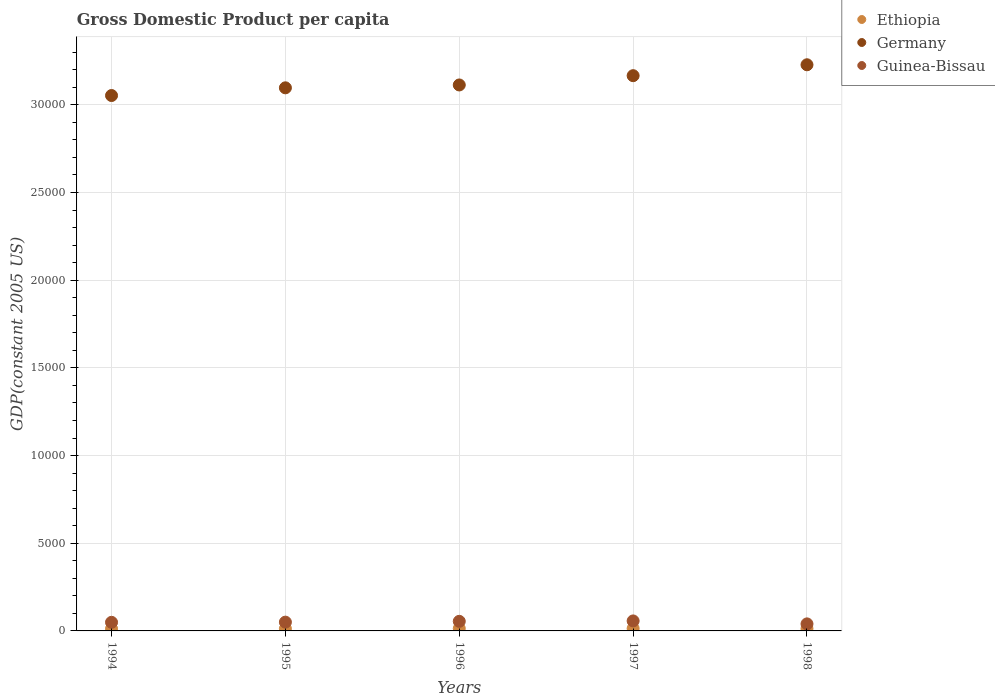What is the GDP per capita in Ethiopia in 1994?
Make the answer very short. 123.73. Across all years, what is the maximum GDP per capita in Guinea-Bissau?
Ensure brevity in your answer.  569.76. Across all years, what is the minimum GDP per capita in Ethiopia?
Offer a terse response. 123.73. In which year was the GDP per capita in Guinea-Bissau maximum?
Make the answer very short. 1997. In which year was the GDP per capita in Ethiopia minimum?
Provide a short and direct response. 1994. What is the total GDP per capita in Guinea-Bissau in the graph?
Ensure brevity in your answer.  2508.49. What is the difference between the GDP per capita in Ethiopia in 1994 and that in 1998?
Give a very brief answer. -6.05. What is the difference between the GDP per capita in Guinea-Bissau in 1998 and the GDP per capita in Ethiopia in 1997?
Your answer should be compact. 262.47. What is the average GDP per capita in Ethiopia per year?
Provide a succinct answer. 131.47. In the year 1994, what is the difference between the GDP per capita in Guinea-Bissau and GDP per capita in Germany?
Make the answer very short. -3.00e+04. What is the ratio of the GDP per capita in Guinea-Bissau in 1997 to that in 1998?
Make the answer very short. 1.42. Is the difference between the GDP per capita in Guinea-Bissau in 1996 and 1997 greater than the difference between the GDP per capita in Germany in 1996 and 1997?
Offer a very short reply. Yes. What is the difference between the highest and the second highest GDP per capita in Guinea-Bissau?
Keep it short and to the point. 23.02. What is the difference between the highest and the lowest GDP per capita in Guinea-Bissau?
Give a very brief answer. 168.85. In how many years, is the GDP per capita in Germany greater than the average GDP per capita in Germany taken over all years?
Your response must be concise. 2. Is the sum of the GDP per capita in Germany in 1994 and 1996 greater than the maximum GDP per capita in Ethiopia across all years?
Your response must be concise. Yes. Is it the case that in every year, the sum of the GDP per capita in Ethiopia and GDP per capita in Guinea-Bissau  is greater than the GDP per capita in Germany?
Your answer should be very brief. No. How many dotlines are there?
Your answer should be very brief. 3. Does the graph contain grids?
Ensure brevity in your answer.  Yes. How many legend labels are there?
Your answer should be compact. 3. How are the legend labels stacked?
Provide a short and direct response. Vertical. What is the title of the graph?
Ensure brevity in your answer.  Gross Domestic Product per capita. Does "Indonesia" appear as one of the legend labels in the graph?
Give a very brief answer. No. What is the label or title of the Y-axis?
Provide a short and direct response. GDP(constant 2005 US). What is the GDP(constant 2005 US) in Ethiopia in 1994?
Offer a very short reply. 123.73. What is the GDP(constant 2005 US) in Germany in 1994?
Your answer should be compact. 3.05e+04. What is the GDP(constant 2005 US) in Guinea-Bissau in 1994?
Provide a short and direct response. 490.34. What is the GDP(constant 2005 US) in Ethiopia in 1995?
Your answer should be very brief. 127.02. What is the GDP(constant 2005 US) of Germany in 1995?
Ensure brevity in your answer.  3.10e+04. What is the GDP(constant 2005 US) in Guinea-Bissau in 1995?
Ensure brevity in your answer.  500.75. What is the GDP(constant 2005 US) in Ethiopia in 1996?
Your response must be concise. 138.36. What is the GDP(constant 2005 US) in Germany in 1996?
Provide a short and direct response. 3.11e+04. What is the GDP(constant 2005 US) of Guinea-Bissau in 1996?
Give a very brief answer. 546.73. What is the GDP(constant 2005 US) in Ethiopia in 1997?
Offer a very short reply. 138.44. What is the GDP(constant 2005 US) in Germany in 1997?
Your answer should be compact. 3.17e+04. What is the GDP(constant 2005 US) in Guinea-Bissau in 1997?
Your response must be concise. 569.76. What is the GDP(constant 2005 US) of Ethiopia in 1998?
Offer a terse response. 129.78. What is the GDP(constant 2005 US) of Germany in 1998?
Ensure brevity in your answer.  3.23e+04. What is the GDP(constant 2005 US) in Guinea-Bissau in 1998?
Provide a succinct answer. 400.91. Across all years, what is the maximum GDP(constant 2005 US) of Ethiopia?
Your answer should be very brief. 138.44. Across all years, what is the maximum GDP(constant 2005 US) of Germany?
Ensure brevity in your answer.  3.23e+04. Across all years, what is the maximum GDP(constant 2005 US) in Guinea-Bissau?
Your answer should be compact. 569.76. Across all years, what is the minimum GDP(constant 2005 US) of Ethiopia?
Offer a very short reply. 123.73. Across all years, what is the minimum GDP(constant 2005 US) of Germany?
Provide a short and direct response. 3.05e+04. Across all years, what is the minimum GDP(constant 2005 US) in Guinea-Bissau?
Ensure brevity in your answer.  400.91. What is the total GDP(constant 2005 US) in Ethiopia in the graph?
Offer a terse response. 657.33. What is the total GDP(constant 2005 US) in Germany in the graph?
Give a very brief answer. 1.57e+05. What is the total GDP(constant 2005 US) in Guinea-Bissau in the graph?
Provide a short and direct response. 2508.49. What is the difference between the GDP(constant 2005 US) in Ethiopia in 1994 and that in 1995?
Offer a terse response. -3.29. What is the difference between the GDP(constant 2005 US) of Germany in 1994 and that in 1995?
Make the answer very short. -439.34. What is the difference between the GDP(constant 2005 US) of Guinea-Bissau in 1994 and that in 1995?
Keep it short and to the point. -10.41. What is the difference between the GDP(constant 2005 US) in Ethiopia in 1994 and that in 1996?
Provide a short and direct response. -14.63. What is the difference between the GDP(constant 2005 US) in Germany in 1994 and that in 1996?
Your answer should be very brief. -602.39. What is the difference between the GDP(constant 2005 US) of Guinea-Bissau in 1994 and that in 1996?
Offer a very short reply. -56.39. What is the difference between the GDP(constant 2005 US) in Ethiopia in 1994 and that in 1997?
Offer a terse response. -14.71. What is the difference between the GDP(constant 2005 US) of Germany in 1994 and that in 1997?
Keep it short and to the point. -1131.72. What is the difference between the GDP(constant 2005 US) in Guinea-Bissau in 1994 and that in 1997?
Ensure brevity in your answer.  -79.42. What is the difference between the GDP(constant 2005 US) in Ethiopia in 1994 and that in 1998?
Your response must be concise. -6.05. What is the difference between the GDP(constant 2005 US) of Germany in 1994 and that in 1998?
Ensure brevity in your answer.  -1753.6. What is the difference between the GDP(constant 2005 US) in Guinea-Bissau in 1994 and that in 1998?
Provide a short and direct response. 89.43. What is the difference between the GDP(constant 2005 US) of Ethiopia in 1995 and that in 1996?
Offer a terse response. -11.34. What is the difference between the GDP(constant 2005 US) in Germany in 1995 and that in 1996?
Provide a short and direct response. -163.04. What is the difference between the GDP(constant 2005 US) of Guinea-Bissau in 1995 and that in 1996?
Offer a terse response. -45.99. What is the difference between the GDP(constant 2005 US) of Ethiopia in 1995 and that in 1997?
Offer a very short reply. -11.42. What is the difference between the GDP(constant 2005 US) of Germany in 1995 and that in 1997?
Provide a succinct answer. -692.38. What is the difference between the GDP(constant 2005 US) in Guinea-Bissau in 1995 and that in 1997?
Offer a terse response. -69.01. What is the difference between the GDP(constant 2005 US) in Ethiopia in 1995 and that in 1998?
Your answer should be compact. -2.76. What is the difference between the GDP(constant 2005 US) of Germany in 1995 and that in 1998?
Keep it short and to the point. -1314.26. What is the difference between the GDP(constant 2005 US) in Guinea-Bissau in 1995 and that in 1998?
Provide a succinct answer. 99.83. What is the difference between the GDP(constant 2005 US) of Ethiopia in 1996 and that in 1997?
Give a very brief answer. -0.08. What is the difference between the GDP(constant 2005 US) of Germany in 1996 and that in 1997?
Provide a short and direct response. -529.33. What is the difference between the GDP(constant 2005 US) in Guinea-Bissau in 1996 and that in 1997?
Make the answer very short. -23.02. What is the difference between the GDP(constant 2005 US) in Ethiopia in 1996 and that in 1998?
Make the answer very short. 8.58. What is the difference between the GDP(constant 2005 US) of Germany in 1996 and that in 1998?
Keep it short and to the point. -1151.22. What is the difference between the GDP(constant 2005 US) of Guinea-Bissau in 1996 and that in 1998?
Offer a terse response. 145.82. What is the difference between the GDP(constant 2005 US) of Ethiopia in 1997 and that in 1998?
Provide a succinct answer. 8.65. What is the difference between the GDP(constant 2005 US) in Germany in 1997 and that in 1998?
Make the answer very short. -621.88. What is the difference between the GDP(constant 2005 US) of Guinea-Bissau in 1997 and that in 1998?
Provide a succinct answer. 168.85. What is the difference between the GDP(constant 2005 US) in Ethiopia in 1994 and the GDP(constant 2005 US) in Germany in 1995?
Your answer should be compact. -3.08e+04. What is the difference between the GDP(constant 2005 US) of Ethiopia in 1994 and the GDP(constant 2005 US) of Guinea-Bissau in 1995?
Offer a very short reply. -377.02. What is the difference between the GDP(constant 2005 US) of Germany in 1994 and the GDP(constant 2005 US) of Guinea-Bissau in 1995?
Ensure brevity in your answer.  3.00e+04. What is the difference between the GDP(constant 2005 US) in Ethiopia in 1994 and the GDP(constant 2005 US) in Germany in 1996?
Provide a succinct answer. -3.10e+04. What is the difference between the GDP(constant 2005 US) in Ethiopia in 1994 and the GDP(constant 2005 US) in Guinea-Bissau in 1996?
Your answer should be compact. -423. What is the difference between the GDP(constant 2005 US) of Germany in 1994 and the GDP(constant 2005 US) of Guinea-Bissau in 1996?
Ensure brevity in your answer.  3.00e+04. What is the difference between the GDP(constant 2005 US) in Ethiopia in 1994 and the GDP(constant 2005 US) in Germany in 1997?
Ensure brevity in your answer.  -3.15e+04. What is the difference between the GDP(constant 2005 US) of Ethiopia in 1994 and the GDP(constant 2005 US) of Guinea-Bissau in 1997?
Offer a very short reply. -446.03. What is the difference between the GDP(constant 2005 US) in Germany in 1994 and the GDP(constant 2005 US) in Guinea-Bissau in 1997?
Provide a succinct answer. 3.00e+04. What is the difference between the GDP(constant 2005 US) in Ethiopia in 1994 and the GDP(constant 2005 US) in Germany in 1998?
Ensure brevity in your answer.  -3.22e+04. What is the difference between the GDP(constant 2005 US) of Ethiopia in 1994 and the GDP(constant 2005 US) of Guinea-Bissau in 1998?
Provide a short and direct response. -277.18. What is the difference between the GDP(constant 2005 US) of Germany in 1994 and the GDP(constant 2005 US) of Guinea-Bissau in 1998?
Offer a very short reply. 3.01e+04. What is the difference between the GDP(constant 2005 US) in Ethiopia in 1995 and the GDP(constant 2005 US) in Germany in 1996?
Your response must be concise. -3.10e+04. What is the difference between the GDP(constant 2005 US) of Ethiopia in 1995 and the GDP(constant 2005 US) of Guinea-Bissau in 1996?
Ensure brevity in your answer.  -419.71. What is the difference between the GDP(constant 2005 US) in Germany in 1995 and the GDP(constant 2005 US) in Guinea-Bissau in 1996?
Offer a terse response. 3.04e+04. What is the difference between the GDP(constant 2005 US) in Ethiopia in 1995 and the GDP(constant 2005 US) in Germany in 1997?
Keep it short and to the point. -3.15e+04. What is the difference between the GDP(constant 2005 US) of Ethiopia in 1995 and the GDP(constant 2005 US) of Guinea-Bissau in 1997?
Keep it short and to the point. -442.74. What is the difference between the GDP(constant 2005 US) of Germany in 1995 and the GDP(constant 2005 US) of Guinea-Bissau in 1997?
Keep it short and to the point. 3.04e+04. What is the difference between the GDP(constant 2005 US) in Ethiopia in 1995 and the GDP(constant 2005 US) in Germany in 1998?
Provide a short and direct response. -3.22e+04. What is the difference between the GDP(constant 2005 US) in Ethiopia in 1995 and the GDP(constant 2005 US) in Guinea-Bissau in 1998?
Offer a very short reply. -273.89. What is the difference between the GDP(constant 2005 US) in Germany in 1995 and the GDP(constant 2005 US) in Guinea-Bissau in 1998?
Your response must be concise. 3.06e+04. What is the difference between the GDP(constant 2005 US) in Ethiopia in 1996 and the GDP(constant 2005 US) in Germany in 1997?
Make the answer very short. -3.15e+04. What is the difference between the GDP(constant 2005 US) of Ethiopia in 1996 and the GDP(constant 2005 US) of Guinea-Bissau in 1997?
Ensure brevity in your answer.  -431.4. What is the difference between the GDP(constant 2005 US) of Germany in 1996 and the GDP(constant 2005 US) of Guinea-Bissau in 1997?
Keep it short and to the point. 3.06e+04. What is the difference between the GDP(constant 2005 US) in Ethiopia in 1996 and the GDP(constant 2005 US) in Germany in 1998?
Offer a very short reply. -3.21e+04. What is the difference between the GDP(constant 2005 US) in Ethiopia in 1996 and the GDP(constant 2005 US) in Guinea-Bissau in 1998?
Make the answer very short. -262.55. What is the difference between the GDP(constant 2005 US) in Germany in 1996 and the GDP(constant 2005 US) in Guinea-Bissau in 1998?
Offer a very short reply. 3.07e+04. What is the difference between the GDP(constant 2005 US) in Ethiopia in 1997 and the GDP(constant 2005 US) in Germany in 1998?
Keep it short and to the point. -3.21e+04. What is the difference between the GDP(constant 2005 US) in Ethiopia in 1997 and the GDP(constant 2005 US) in Guinea-Bissau in 1998?
Your answer should be very brief. -262.47. What is the difference between the GDP(constant 2005 US) in Germany in 1997 and the GDP(constant 2005 US) in Guinea-Bissau in 1998?
Your answer should be compact. 3.13e+04. What is the average GDP(constant 2005 US) of Ethiopia per year?
Make the answer very short. 131.47. What is the average GDP(constant 2005 US) in Germany per year?
Offer a terse response. 3.13e+04. What is the average GDP(constant 2005 US) of Guinea-Bissau per year?
Your answer should be compact. 501.7. In the year 1994, what is the difference between the GDP(constant 2005 US) in Ethiopia and GDP(constant 2005 US) in Germany?
Provide a short and direct response. -3.04e+04. In the year 1994, what is the difference between the GDP(constant 2005 US) of Ethiopia and GDP(constant 2005 US) of Guinea-Bissau?
Your answer should be very brief. -366.61. In the year 1994, what is the difference between the GDP(constant 2005 US) in Germany and GDP(constant 2005 US) in Guinea-Bissau?
Make the answer very short. 3.00e+04. In the year 1995, what is the difference between the GDP(constant 2005 US) in Ethiopia and GDP(constant 2005 US) in Germany?
Ensure brevity in your answer.  -3.08e+04. In the year 1995, what is the difference between the GDP(constant 2005 US) in Ethiopia and GDP(constant 2005 US) in Guinea-Bissau?
Give a very brief answer. -373.73. In the year 1995, what is the difference between the GDP(constant 2005 US) in Germany and GDP(constant 2005 US) in Guinea-Bissau?
Keep it short and to the point. 3.05e+04. In the year 1996, what is the difference between the GDP(constant 2005 US) in Ethiopia and GDP(constant 2005 US) in Germany?
Give a very brief answer. -3.10e+04. In the year 1996, what is the difference between the GDP(constant 2005 US) of Ethiopia and GDP(constant 2005 US) of Guinea-Bissau?
Keep it short and to the point. -408.38. In the year 1996, what is the difference between the GDP(constant 2005 US) in Germany and GDP(constant 2005 US) in Guinea-Bissau?
Ensure brevity in your answer.  3.06e+04. In the year 1997, what is the difference between the GDP(constant 2005 US) in Ethiopia and GDP(constant 2005 US) in Germany?
Provide a succinct answer. -3.15e+04. In the year 1997, what is the difference between the GDP(constant 2005 US) of Ethiopia and GDP(constant 2005 US) of Guinea-Bissau?
Your answer should be compact. -431.32. In the year 1997, what is the difference between the GDP(constant 2005 US) of Germany and GDP(constant 2005 US) of Guinea-Bissau?
Make the answer very short. 3.11e+04. In the year 1998, what is the difference between the GDP(constant 2005 US) of Ethiopia and GDP(constant 2005 US) of Germany?
Give a very brief answer. -3.22e+04. In the year 1998, what is the difference between the GDP(constant 2005 US) in Ethiopia and GDP(constant 2005 US) in Guinea-Bissau?
Your answer should be compact. -271.13. In the year 1998, what is the difference between the GDP(constant 2005 US) of Germany and GDP(constant 2005 US) of Guinea-Bissau?
Make the answer very short. 3.19e+04. What is the ratio of the GDP(constant 2005 US) of Ethiopia in 1994 to that in 1995?
Give a very brief answer. 0.97. What is the ratio of the GDP(constant 2005 US) in Germany in 1994 to that in 1995?
Give a very brief answer. 0.99. What is the ratio of the GDP(constant 2005 US) in Guinea-Bissau in 1994 to that in 1995?
Offer a terse response. 0.98. What is the ratio of the GDP(constant 2005 US) in Ethiopia in 1994 to that in 1996?
Offer a terse response. 0.89. What is the ratio of the GDP(constant 2005 US) of Germany in 1994 to that in 1996?
Give a very brief answer. 0.98. What is the ratio of the GDP(constant 2005 US) in Guinea-Bissau in 1994 to that in 1996?
Your response must be concise. 0.9. What is the ratio of the GDP(constant 2005 US) of Ethiopia in 1994 to that in 1997?
Your answer should be compact. 0.89. What is the ratio of the GDP(constant 2005 US) of Guinea-Bissau in 1994 to that in 1997?
Provide a succinct answer. 0.86. What is the ratio of the GDP(constant 2005 US) of Ethiopia in 1994 to that in 1998?
Provide a succinct answer. 0.95. What is the ratio of the GDP(constant 2005 US) of Germany in 1994 to that in 1998?
Your answer should be very brief. 0.95. What is the ratio of the GDP(constant 2005 US) of Guinea-Bissau in 1994 to that in 1998?
Your response must be concise. 1.22. What is the ratio of the GDP(constant 2005 US) in Ethiopia in 1995 to that in 1996?
Provide a short and direct response. 0.92. What is the ratio of the GDP(constant 2005 US) of Guinea-Bissau in 1995 to that in 1996?
Provide a succinct answer. 0.92. What is the ratio of the GDP(constant 2005 US) in Ethiopia in 1995 to that in 1997?
Offer a very short reply. 0.92. What is the ratio of the GDP(constant 2005 US) of Germany in 1995 to that in 1997?
Provide a short and direct response. 0.98. What is the ratio of the GDP(constant 2005 US) of Guinea-Bissau in 1995 to that in 1997?
Your response must be concise. 0.88. What is the ratio of the GDP(constant 2005 US) in Ethiopia in 1995 to that in 1998?
Your answer should be very brief. 0.98. What is the ratio of the GDP(constant 2005 US) of Germany in 1995 to that in 1998?
Keep it short and to the point. 0.96. What is the ratio of the GDP(constant 2005 US) of Guinea-Bissau in 1995 to that in 1998?
Your response must be concise. 1.25. What is the ratio of the GDP(constant 2005 US) in Germany in 1996 to that in 1997?
Ensure brevity in your answer.  0.98. What is the ratio of the GDP(constant 2005 US) in Guinea-Bissau in 1996 to that in 1997?
Keep it short and to the point. 0.96. What is the ratio of the GDP(constant 2005 US) in Ethiopia in 1996 to that in 1998?
Give a very brief answer. 1.07. What is the ratio of the GDP(constant 2005 US) in Germany in 1996 to that in 1998?
Your response must be concise. 0.96. What is the ratio of the GDP(constant 2005 US) in Guinea-Bissau in 1996 to that in 1998?
Ensure brevity in your answer.  1.36. What is the ratio of the GDP(constant 2005 US) of Ethiopia in 1997 to that in 1998?
Provide a short and direct response. 1.07. What is the ratio of the GDP(constant 2005 US) in Germany in 1997 to that in 1998?
Offer a terse response. 0.98. What is the ratio of the GDP(constant 2005 US) of Guinea-Bissau in 1997 to that in 1998?
Your response must be concise. 1.42. What is the difference between the highest and the second highest GDP(constant 2005 US) of Ethiopia?
Make the answer very short. 0.08. What is the difference between the highest and the second highest GDP(constant 2005 US) in Germany?
Provide a short and direct response. 621.88. What is the difference between the highest and the second highest GDP(constant 2005 US) of Guinea-Bissau?
Provide a succinct answer. 23.02. What is the difference between the highest and the lowest GDP(constant 2005 US) in Ethiopia?
Make the answer very short. 14.71. What is the difference between the highest and the lowest GDP(constant 2005 US) in Germany?
Keep it short and to the point. 1753.6. What is the difference between the highest and the lowest GDP(constant 2005 US) of Guinea-Bissau?
Offer a terse response. 168.85. 